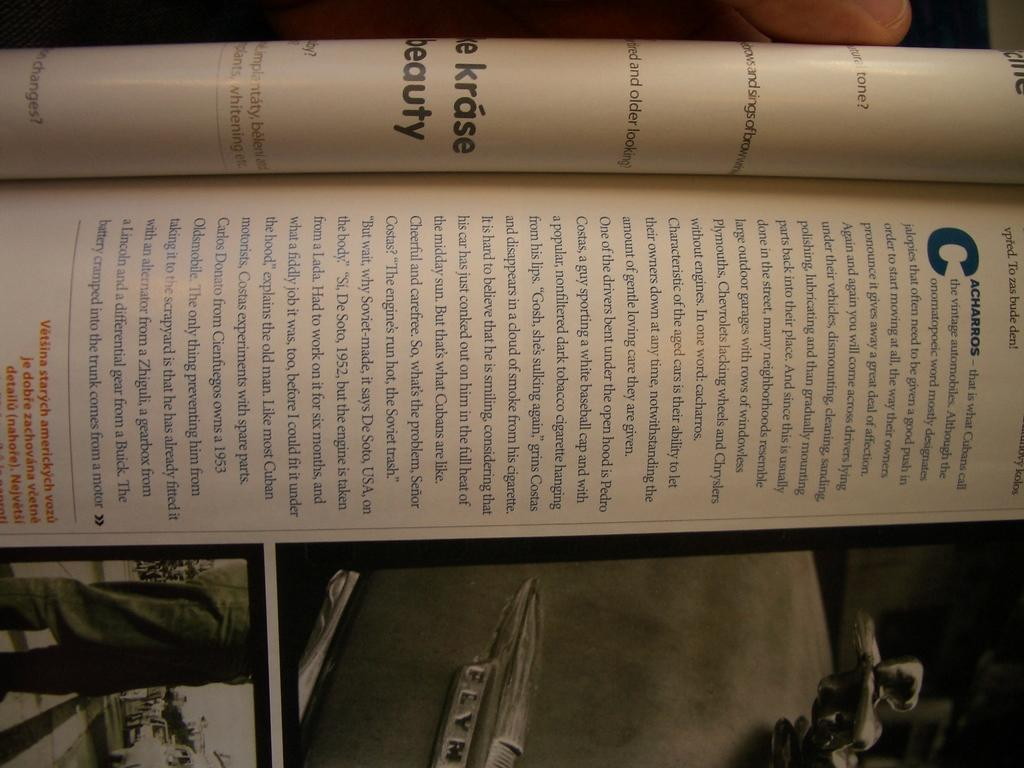<image>
Provide a brief description of the given image. The trunk of a Plymouth automobile is partially visible on one page of an opened magazine. 